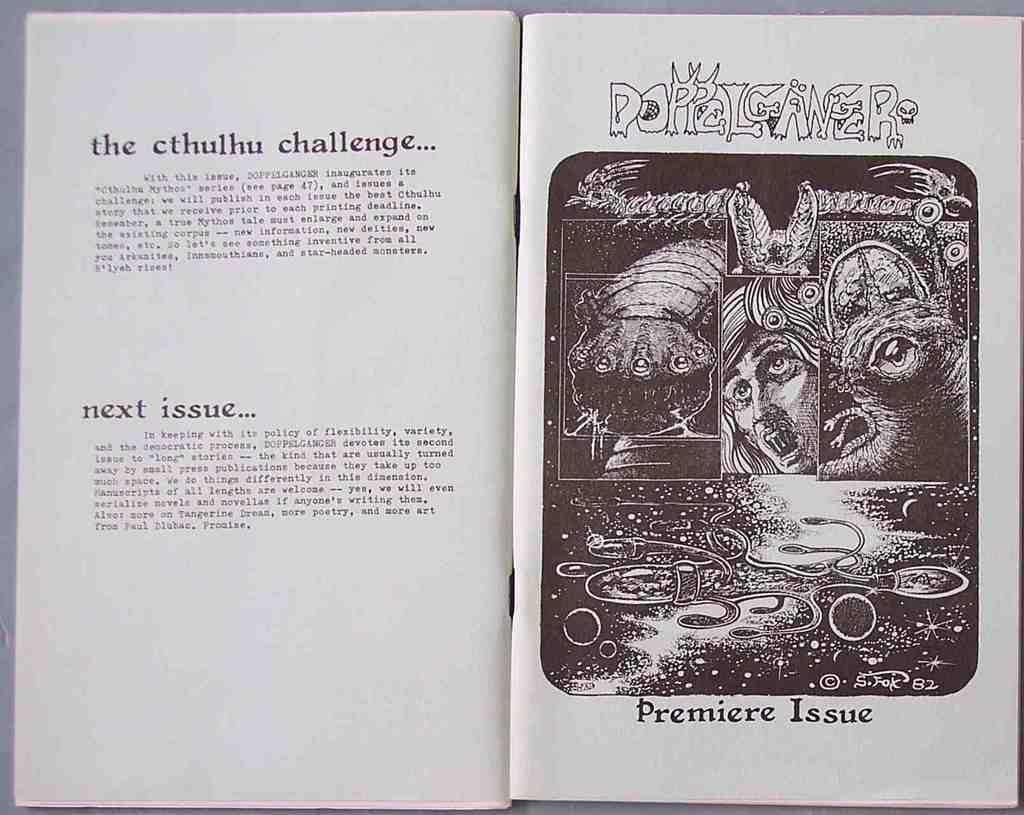The title of the article says what type of challenge?
Your answer should be very brief. The cthulhu challenge. 